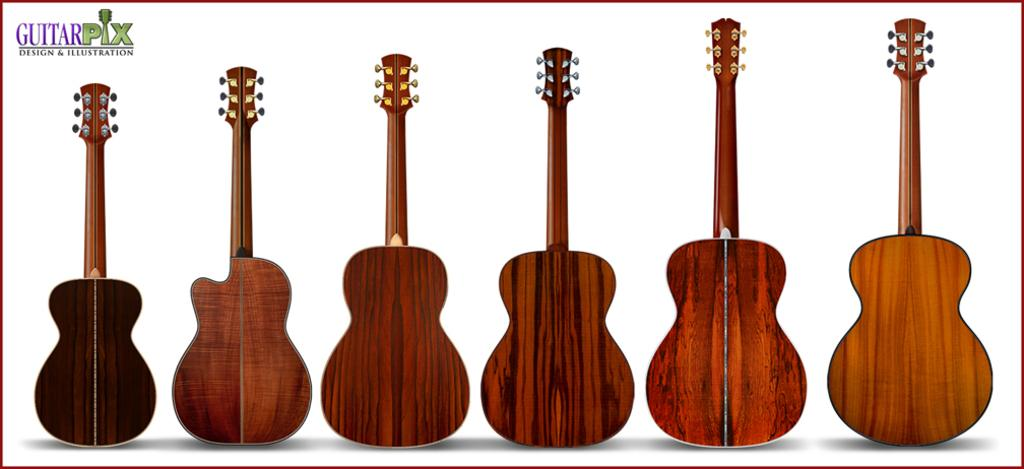What material are the guitars made of in the image? The guitars in the image are made of wood. Can you describe the text in the image? There is a text located in the top left corner of the image. What color is the crayon used to write the text in the image? There is no crayon present in the image, as the text is not written with a crayon. 